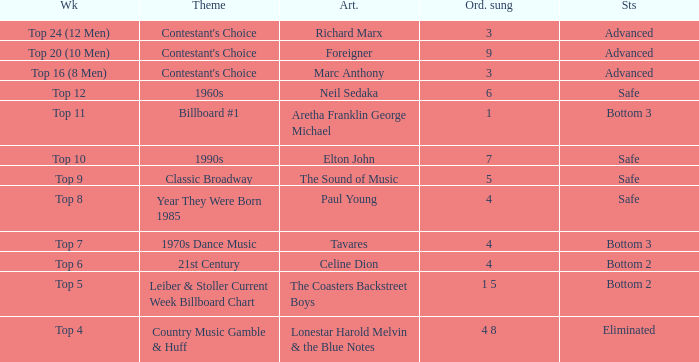What week did the contestant finish in the bottom 2 with a Celine Dion song? Top 6. 